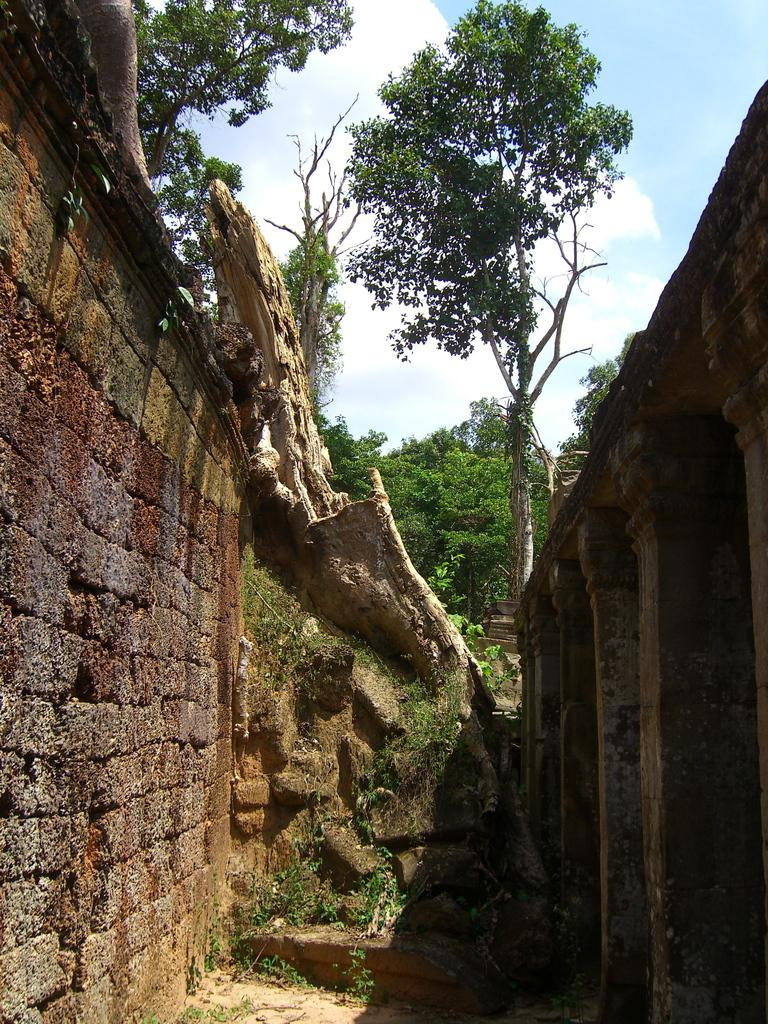What type of architectural feature can be seen in the image? There are pillars in the image. What else can be seen in the image besides the pillars? There is a wall, trees, plants, and the sky visible in the image. What type of vegetation is present in the image? There are trees and plants in the image. What is visible in the sky in the image? The sky is visible in the image, and clouds are present. What color is the paint on the magic hole in the image? There is no mention of paint, magic, or a hole in the image. The image features pillars, a wall, trees, plants, and the sky with clouds. 